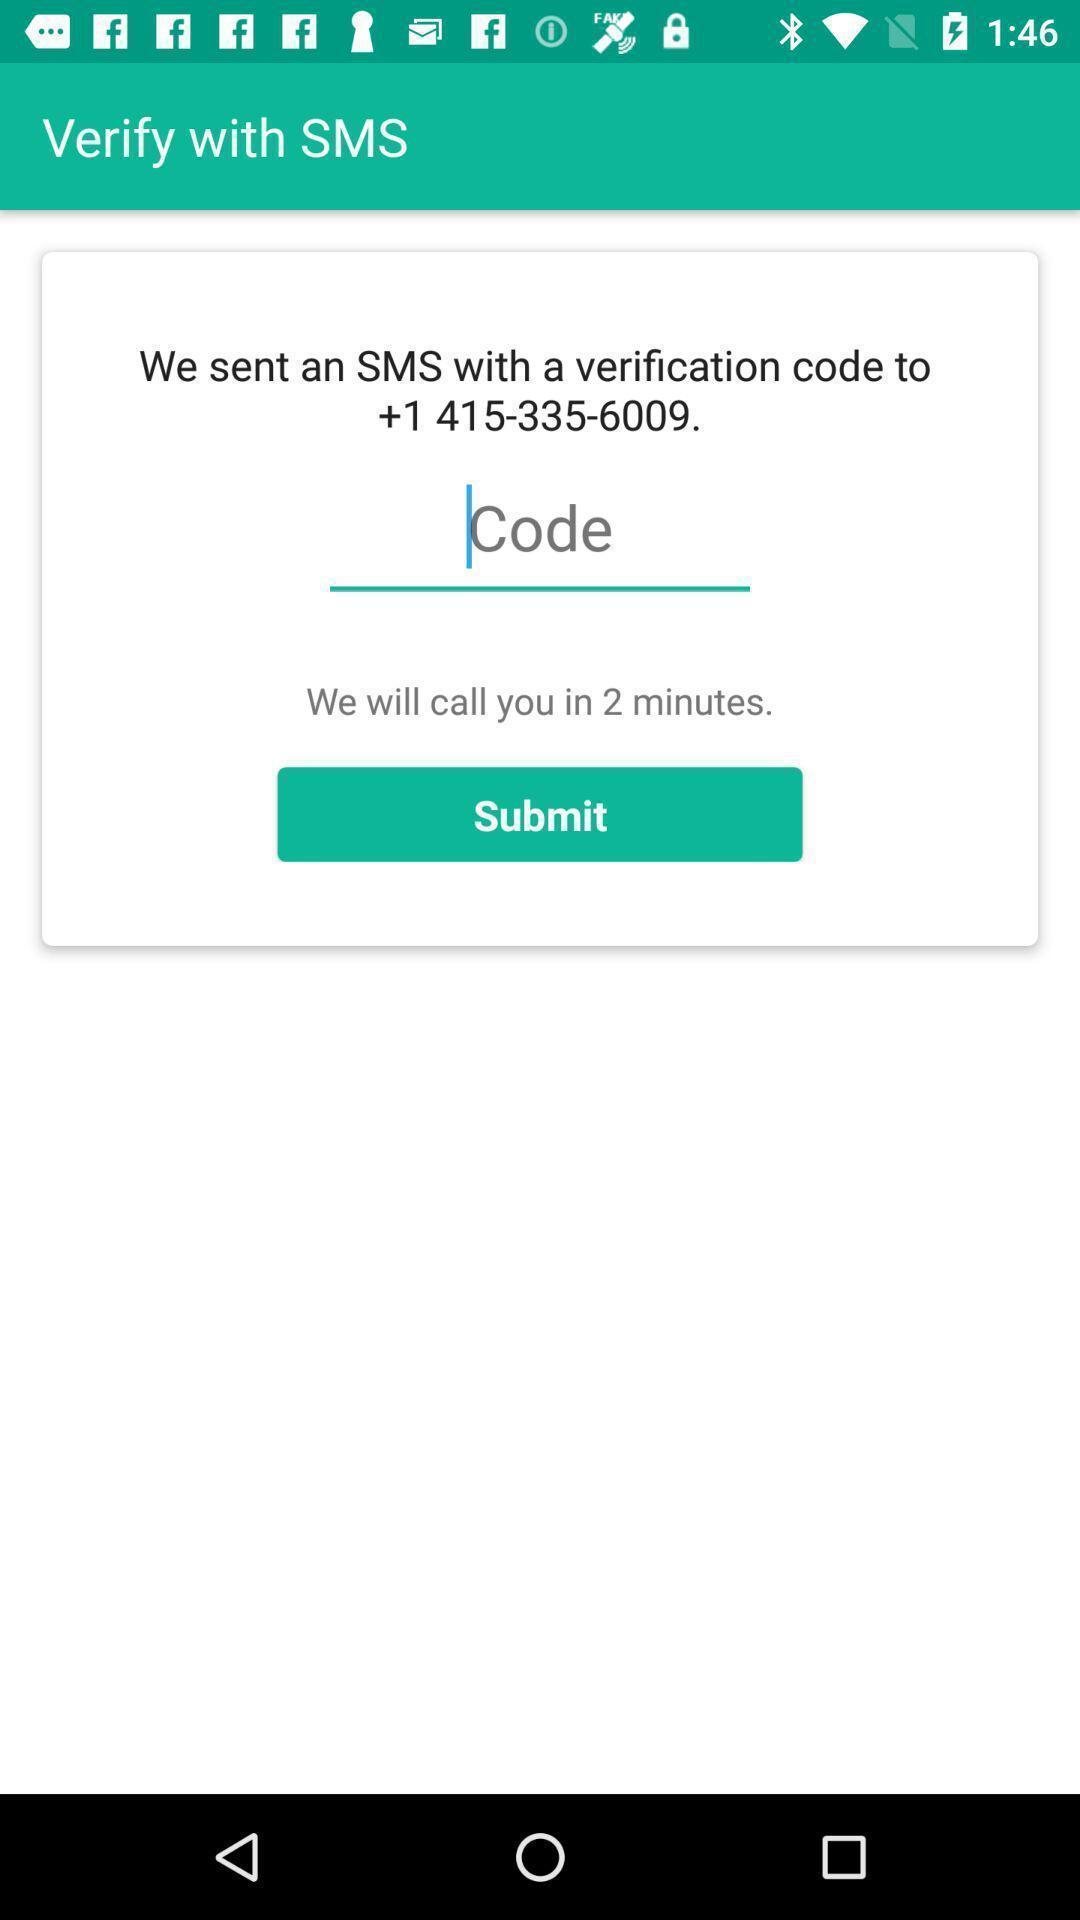Please provide a description for this image. Screen page displaying to enter the code. 